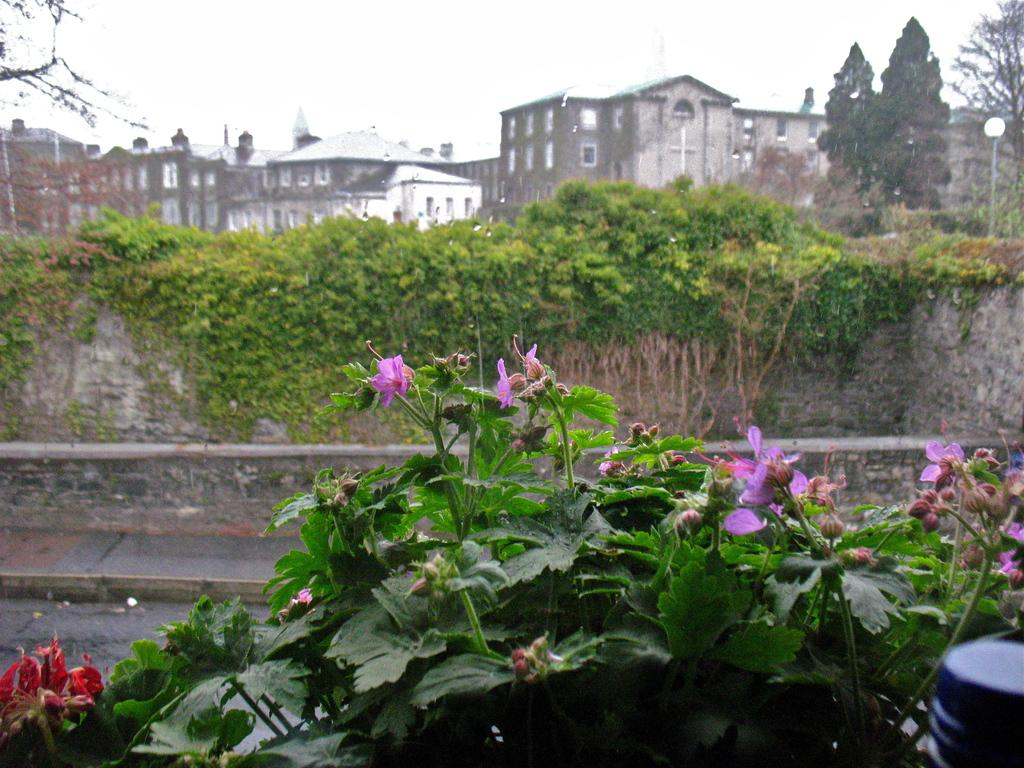What types of living organisms can be seen in the image? Plants and flowers are visible in the image. What can be seen in the background of the image? There is a wall, buildings, an electric pole with a light, trees, and some unspecified objects in the background of the image. What is visible in the sky in the image? The sky is visible in the background of the image. What type of pest can be seen crawling on the flowers in the image? There is no pest visible on the flowers in the image. What type of lamp is used to illuminate the area in the image? There is no lamp present in the image; only an electric pole with a light is visible. 